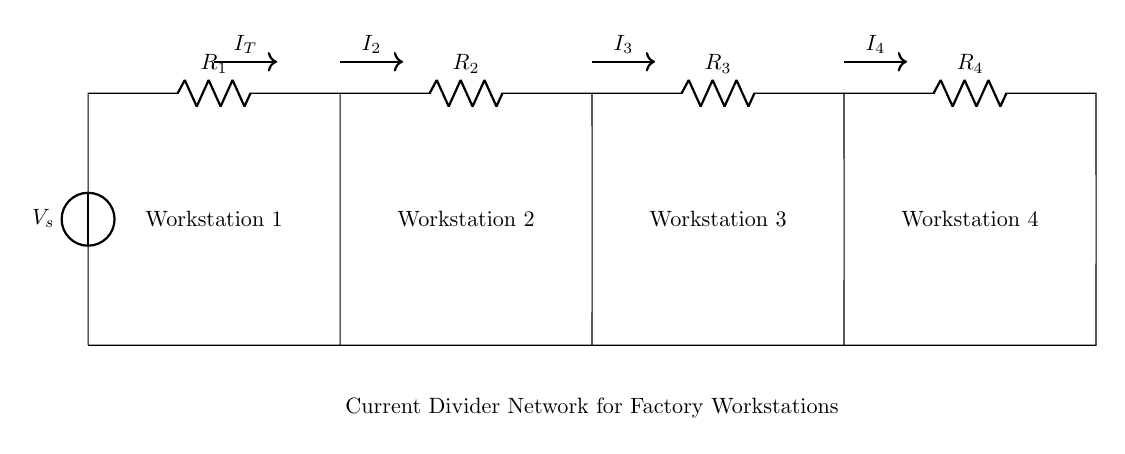What is the source voltage in this circuit? The source voltage is denoted as V_s on the left side of the circuit diagram.
Answer: V_s How many resistors are present in the circuit? The circuit contains four resistors, labeled R_1, R_2, R_3, and R_4, aligned horizontally.
Answer: Four Which workstation receives the current labeled I_2? The current I_2 flows to Workstation 2 as indicated by its position in relation to the diagram.
Answer: Workstation 2 What is the configuration of the resistors in this circuit? The resistors R_1, R_2, R_3, and R_4 are arranged in parallel, which divides the total current among them.
Answer: Parallel How do you calculate the individual currents through the resistors? The individual currents can be calculated using the current divider rule, where the current through a resistor is inversely proportional to its resistance relative to the total resistance of the parallel network. Formula: I_n = I_T * (R_total / R_n).
Answer: Current divider rule Which workstation receives the least current? The workstation that is connected to the resistor with the highest resistance will receive the least current, according to the current divider principle.
Answer: Workstation connected to R_4 What is the purpose of a current divider network in a factory? A current divider network is used to distribute electrical power evenly or according to specific needs to multiple workstations or devices while maintaining a stable voltage level.
Answer: Power distribution 